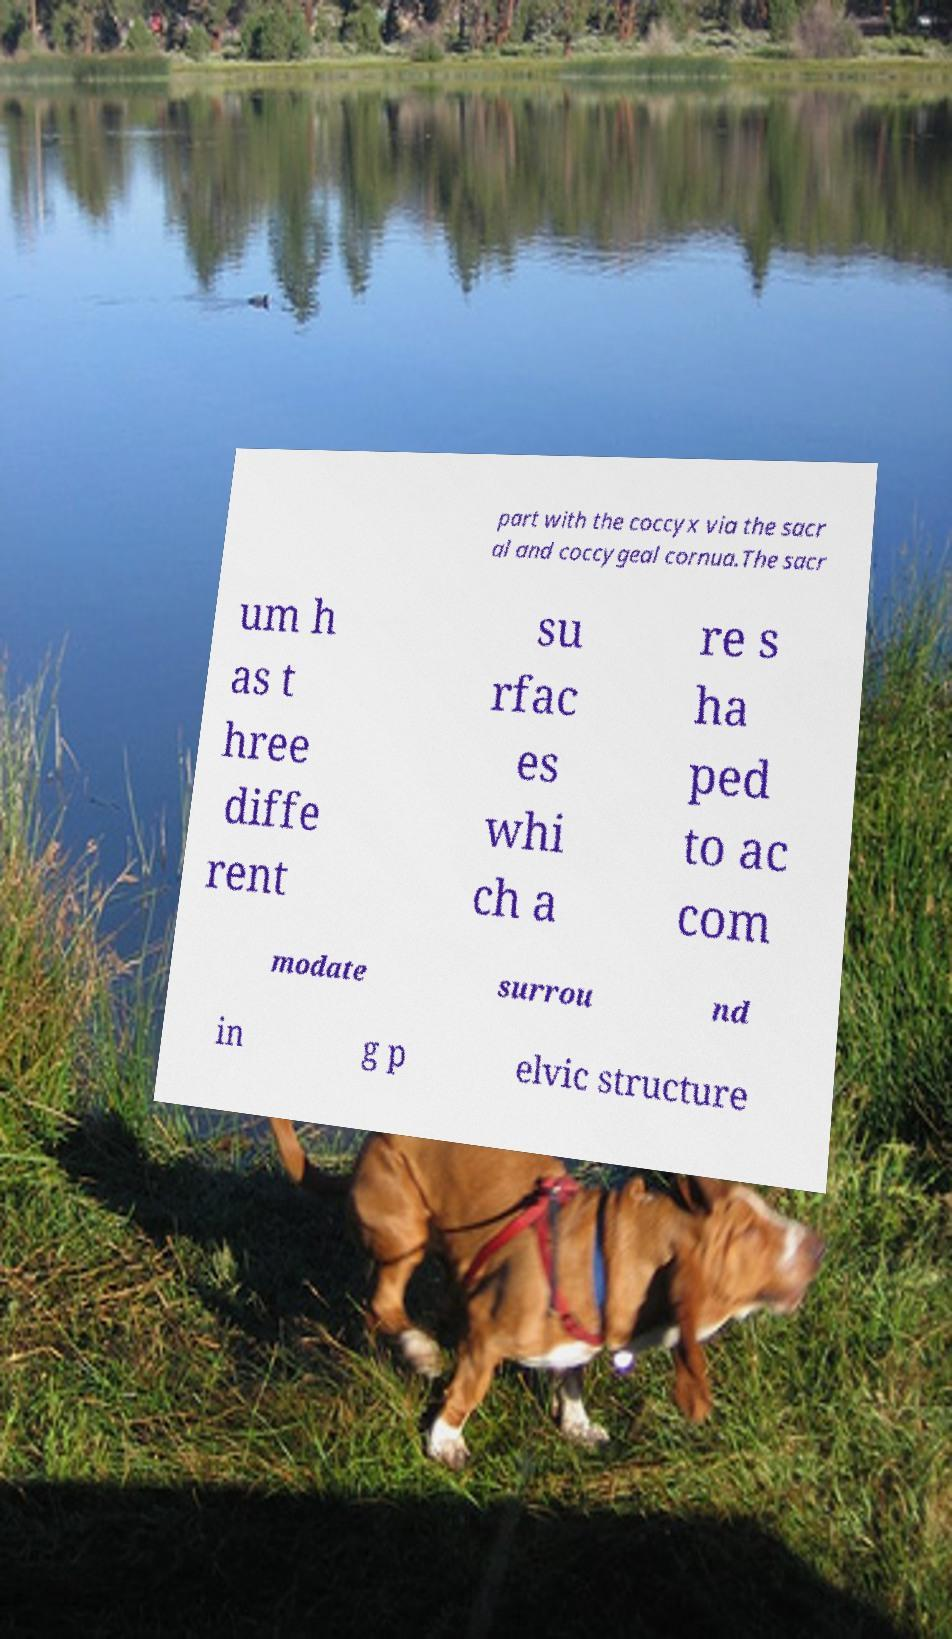For documentation purposes, I need the text within this image transcribed. Could you provide that? part with the coccyx via the sacr al and coccygeal cornua.The sacr um h as t hree diffe rent su rfac es whi ch a re s ha ped to ac com modate surrou nd in g p elvic structure 